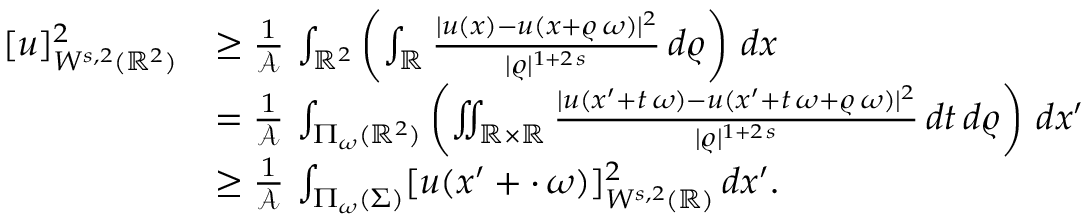<formula> <loc_0><loc_0><loc_500><loc_500>\begin{array} { r l } { [ u ] _ { W ^ { s , 2 } ( \mathbb { R } ^ { 2 } ) } ^ { 2 } } & { \geq \frac { 1 } { \mathcal { A } } \, \int _ { \mathbb { R } ^ { 2 } } \left ( \int _ { \mathbb { R } } \frac { | u ( x ) - u ( x + \varrho \, \omega ) | ^ { 2 } } { | \varrho | ^ { 1 + 2 \, s } } \, d \varrho \right ) \, d x } \\ & { = \frac { 1 } { \mathcal { A } } \, \int _ { \Pi _ { \omega } ( \mathbb { R } ^ { 2 } ) } \left ( \iint _ { \mathbb { R } \times \mathbb { R } } \frac { | u ( x ^ { \prime } + t \, \omega ) - u ( x ^ { \prime } + t \, \omega + \varrho \, \omega ) | ^ { 2 } } { | \varrho | ^ { 1 + 2 \, s } } \, d t \, d \varrho \right ) \, d x ^ { \prime } } \\ & { \geq \frac { 1 } { \mathcal { A } } \, \int _ { \Pi _ { \omega } ( \Sigma ) } [ u ( x ^ { \prime } + \cdot \, \omega ) ] _ { W ^ { s , 2 } ( \mathbb { R } ) } ^ { 2 } \, d x ^ { \prime } . } \end{array}</formula> 